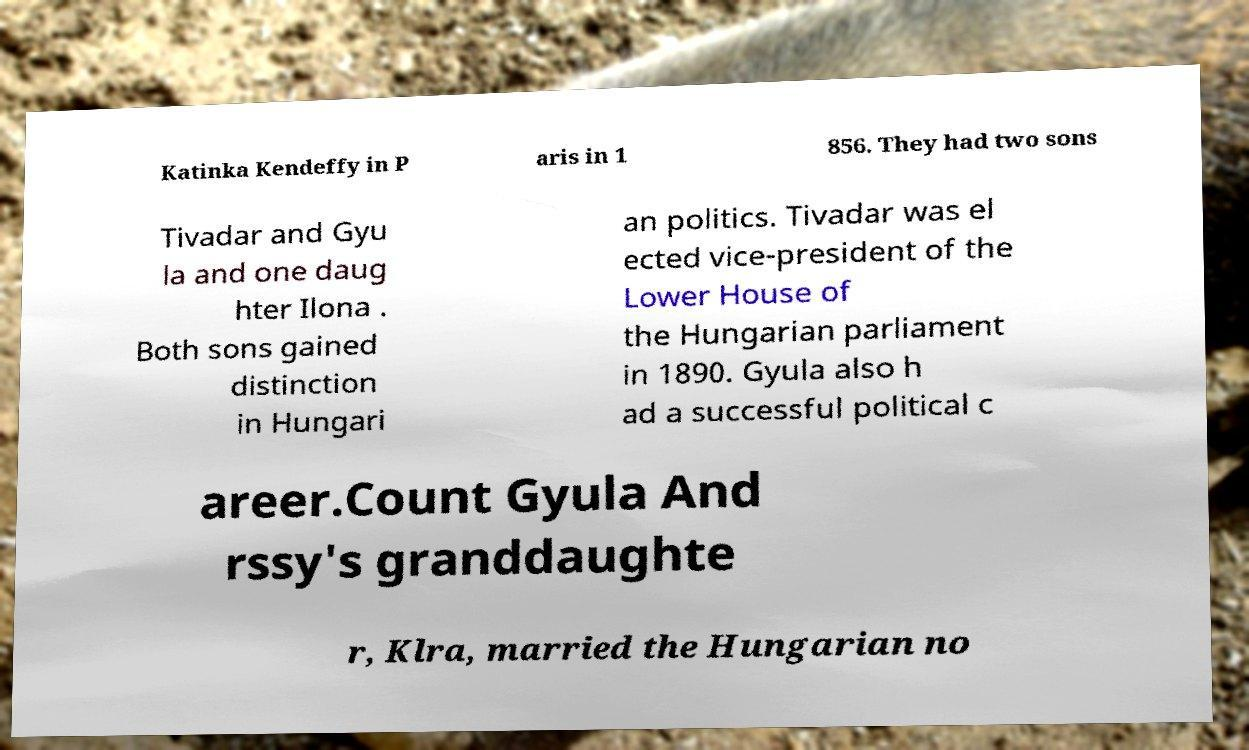Please identify and transcribe the text found in this image. Katinka Kendeffy in P aris in 1 856. They had two sons Tivadar and Gyu la and one daug hter Ilona . Both sons gained distinction in Hungari an politics. Tivadar was el ected vice-president of the Lower House of the Hungarian parliament in 1890. Gyula also h ad a successful political c areer.Count Gyula And rssy's granddaughte r, Klra, married the Hungarian no 